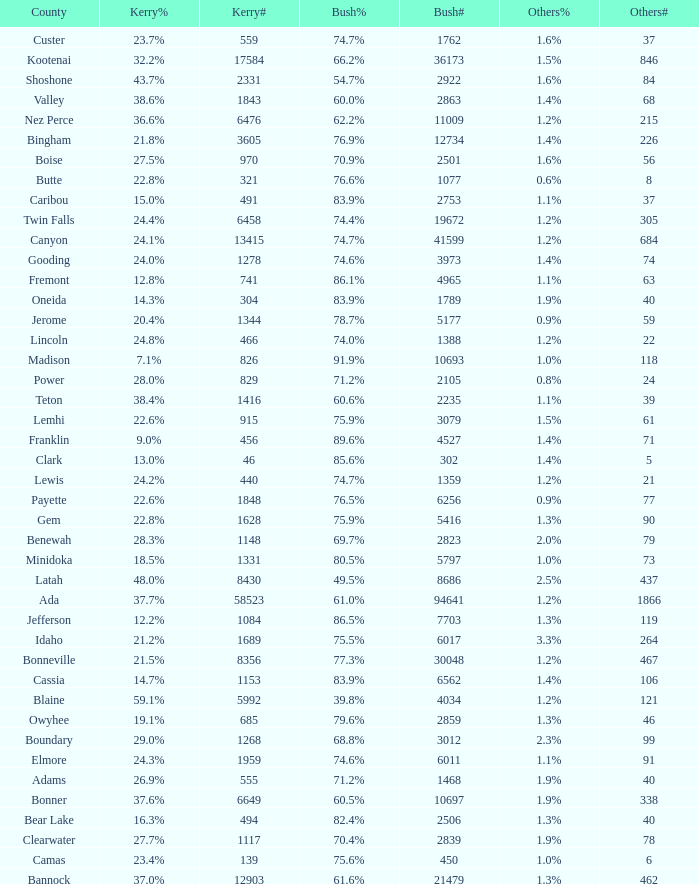What's percentage voted for Busg in the county where Kerry got 37.6%? 60.5%. 